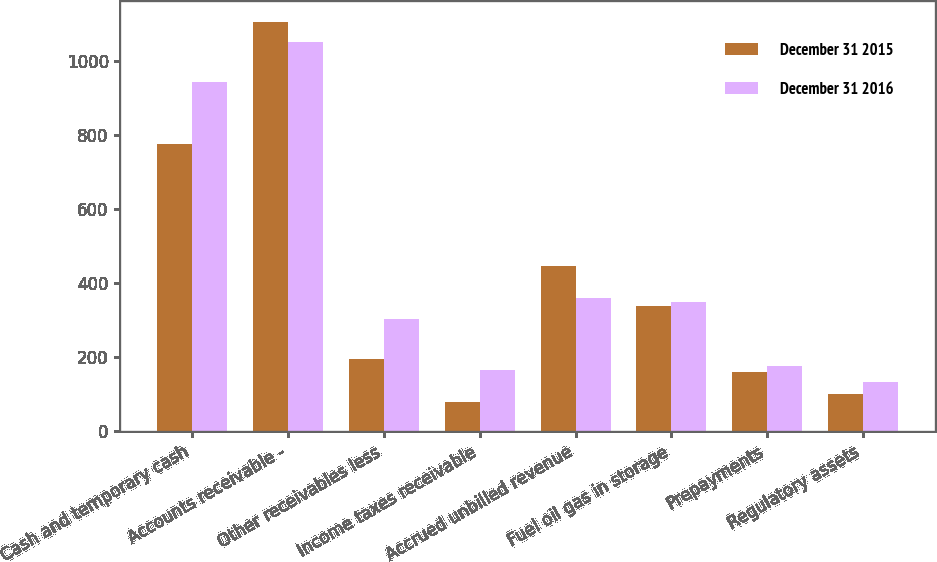Convert chart to OTSL. <chart><loc_0><loc_0><loc_500><loc_500><stacked_bar_chart><ecel><fcel>Cash and temporary cash<fcel>Accounts receivable -<fcel>Other receivables less<fcel>Income taxes receivable<fcel>Accrued unbilled revenue<fcel>Fuel oil gas in storage<fcel>Prepayments<fcel>Regulatory assets<nl><fcel>December 31 2015<fcel>776<fcel>1106<fcel>195<fcel>79<fcel>447<fcel>339<fcel>159<fcel>100<nl><fcel>December 31 2016<fcel>944<fcel>1052<fcel>304<fcel>166<fcel>360<fcel>350<fcel>177<fcel>132<nl></chart> 